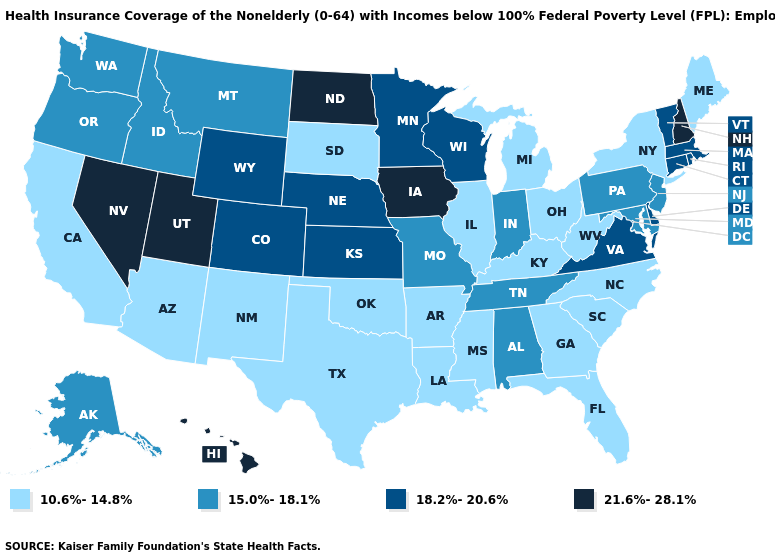What is the value of Arkansas?
Write a very short answer. 10.6%-14.8%. What is the lowest value in the West?
Give a very brief answer. 10.6%-14.8%. Name the states that have a value in the range 10.6%-14.8%?
Concise answer only. Arizona, Arkansas, California, Florida, Georgia, Illinois, Kentucky, Louisiana, Maine, Michigan, Mississippi, New Mexico, New York, North Carolina, Ohio, Oklahoma, South Carolina, South Dakota, Texas, West Virginia. What is the highest value in the MidWest ?
Keep it brief. 21.6%-28.1%. Name the states that have a value in the range 18.2%-20.6%?
Keep it brief. Colorado, Connecticut, Delaware, Kansas, Massachusetts, Minnesota, Nebraska, Rhode Island, Vermont, Virginia, Wisconsin, Wyoming. What is the value of Missouri?
Short answer required. 15.0%-18.1%. Name the states that have a value in the range 10.6%-14.8%?
Be succinct. Arizona, Arkansas, California, Florida, Georgia, Illinois, Kentucky, Louisiana, Maine, Michigan, Mississippi, New Mexico, New York, North Carolina, Ohio, Oklahoma, South Carolina, South Dakota, Texas, West Virginia. Which states have the highest value in the USA?
Answer briefly. Hawaii, Iowa, Nevada, New Hampshire, North Dakota, Utah. Which states have the lowest value in the South?
Write a very short answer. Arkansas, Florida, Georgia, Kentucky, Louisiana, Mississippi, North Carolina, Oklahoma, South Carolina, Texas, West Virginia. What is the value of New Jersey?
Short answer required. 15.0%-18.1%. Does the first symbol in the legend represent the smallest category?
Short answer required. Yes. Name the states that have a value in the range 18.2%-20.6%?
Be succinct. Colorado, Connecticut, Delaware, Kansas, Massachusetts, Minnesota, Nebraska, Rhode Island, Vermont, Virginia, Wisconsin, Wyoming. Among the states that border California , which have the lowest value?
Keep it brief. Arizona. What is the highest value in the USA?
Write a very short answer. 21.6%-28.1%. What is the lowest value in the South?
Concise answer only. 10.6%-14.8%. 